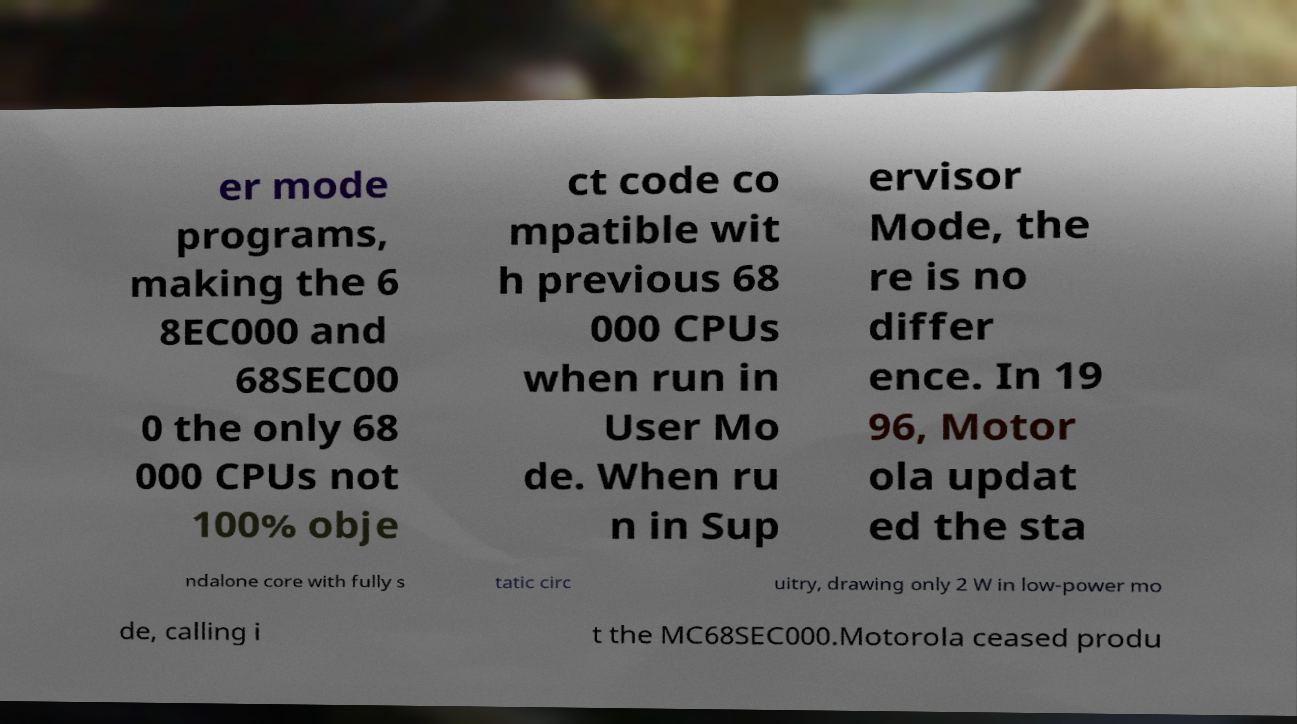Can you read and provide the text displayed in the image?This photo seems to have some interesting text. Can you extract and type it out for me? er mode programs, making the 6 8EC000 and 68SEC00 0 the only 68 000 CPUs not 100% obje ct code co mpatible wit h previous 68 000 CPUs when run in User Mo de. When ru n in Sup ervisor Mode, the re is no differ ence. In 19 96, Motor ola updat ed the sta ndalone core with fully s tatic circ uitry, drawing only 2 W in low-power mo de, calling i t the MC68SEC000.Motorola ceased produ 